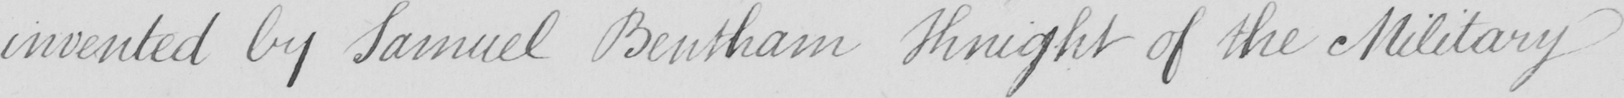Can you tell me what this handwritten text says? invented by Samuel Bentham Knight of the Military 